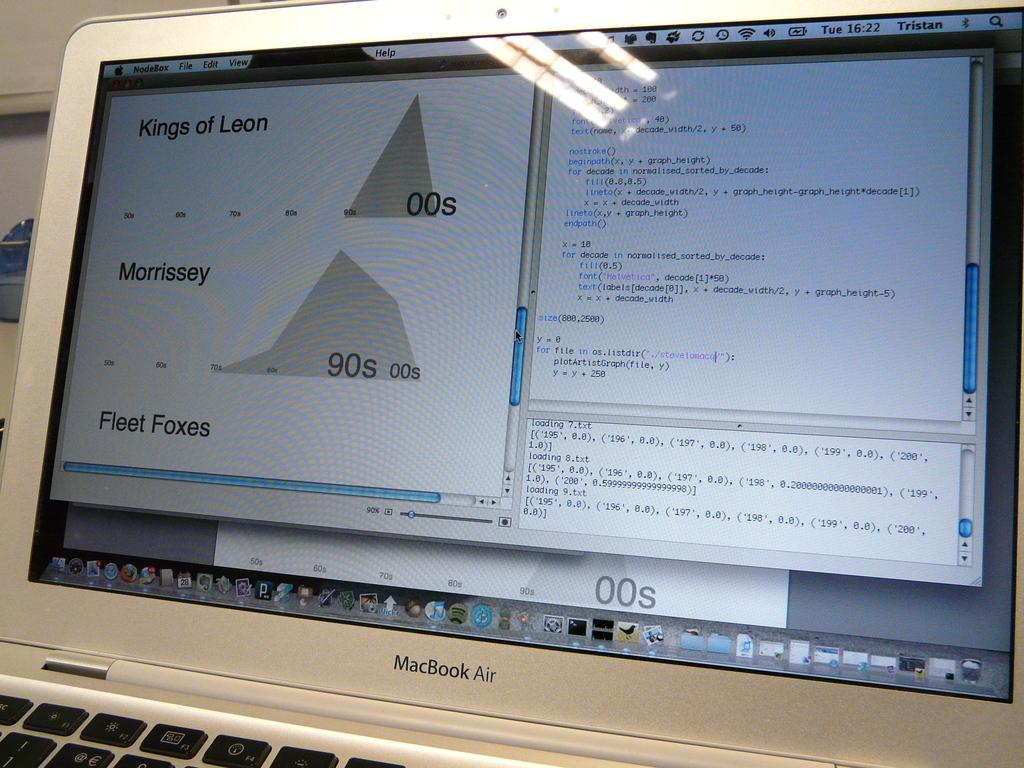Provide a one-sentence caption for the provided image. An open MacBook Air shows a Kings of Leon file. 